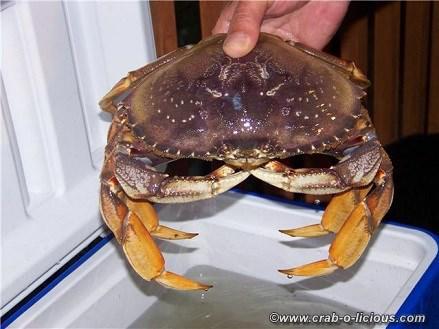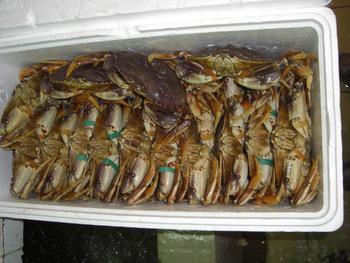The first image is the image on the left, the second image is the image on the right. Assess this claim about the two images: "The image on the right shows red crabs on top of vegetables including corn.". Correct or not? Answer yes or no. No. The first image is the image on the left, the second image is the image on the right. Analyze the images presented: Is the assertion "In one image, a person's hand can be seen holding a single large crab with its legs curled in front." valid? Answer yes or no. Yes. 